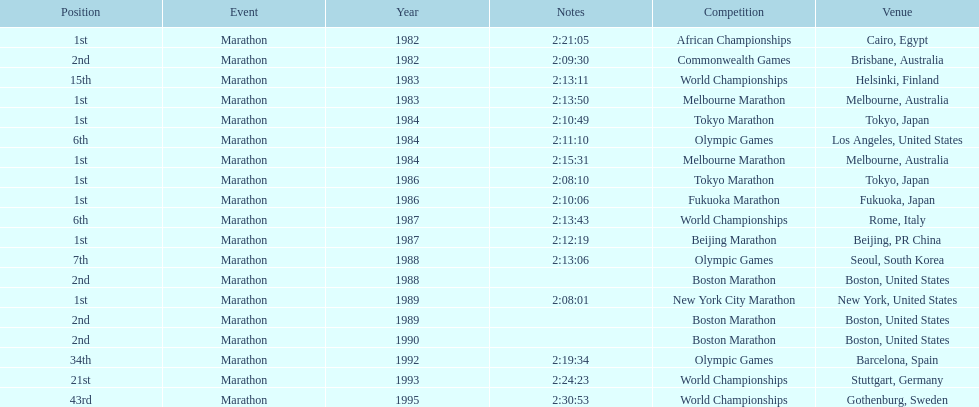What was the first marathon juma ikangaa won? 1982 African Championships. Can you give me this table as a dict? {'header': ['Position', 'Event', 'Year', 'Notes', 'Competition', 'Venue'], 'rows': [['1st', 'Marathon', '1982', '2:21:05', 'African Championships', 'Cairo, Egypt'], ['2nd', 'Marathon', '1982', '2:09:30', 'Commonwealth Games', 'Brisbane, Australia'], ['15th', 'Marathon', '1983', '2:13:11', 'World Championships', 'Helsinki, Finland'], ['1st', 'Marathon', '1983', '2:13:50', 'Melbourne Marathon', 'Melbourne, Australia'], ['1st', 'Marathon', '1984', '2:10:49', 'Tokyo Marathon', 'Tokyo, Japan'], ['6th', 'Marathon', '1984', '2:11:10', 'Olympic Games', 'Los Angeles, United States'], ['1st', 'Marathon', '1984', '2:15:31', 'Melbourne Marathon', 'Melbourne, Australia'], ['1st', 'Marathon', '1986', '2:08:10', 'Tokyo Marathon', 'Tokyo, Japan'], ['1st', 'Marathon', '1986', '2:10:06', 'Fukuoka Marathon', 'Fukuoka, Japan'], ['6th', 'Marathon', '1987', '2:13:43', 'World Championships', 'Rome, Italy'], ['1st', 'Marathon', '1987', '2:12:19', 'Beijing Marathon', 'Beijing, PR China'], ['7th', 'Marathon', '1988', '2:13:06', 'Olympic Games', 'Seoul, South Korea'], ['2nd', 'Marathon', '1988', '', 'Boston Marathon', 'Boston, United States'], ['1st', 'Marathon', '1989', '2:08:01', 'New York City Marathon', 'New York, United States'], ['2nd', 'Marathon', '1989', '', 'Boston Marathon', 'Boston, United States'], ['2nd', 'Marathon', '1990', '', 'Boston Marathon', 'Boston, United States'], ['34th', 'Marathon', '1992', '2:19:34', 'Olympic Games', 'Barcelona, Spain'], ['21st', 'Marathon', '1993', '2:24:23', 'World Championships', 'Stuttgart, Germany'], ['43rd', 'Marathon', '1995', '2:30:53', 'World Championships', 'Gothenburg, Sweden']]} 